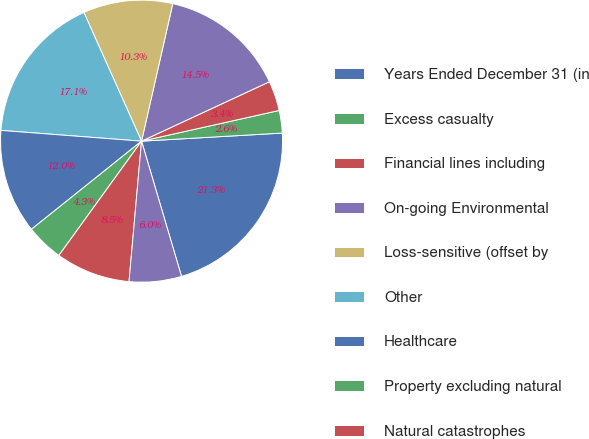Convert chart to OTSL. <chart><loc_0><loc_0><loc_500><loc_500><pie_chart><fcel>Years Ended December 31 (in<fcel>Excess casualty<fcel>Financial lines including<fcel>On-going Environmental<fcel>Loss-sensitive (offset by<fcel>Other<fcel>Healthcare<fcel>Property excluding natural<fcel>Natural catastrophes<fcel>All other net<nl><fcel>21.34%<fcel>2.58%<fcel>3.43%<fcel>14.52%<fcel>10.26%<fcel>17.08%<fcel>11.96%<fcel>4.29%<fcel>8.55%<fcel>5.99%<nl></chart> 